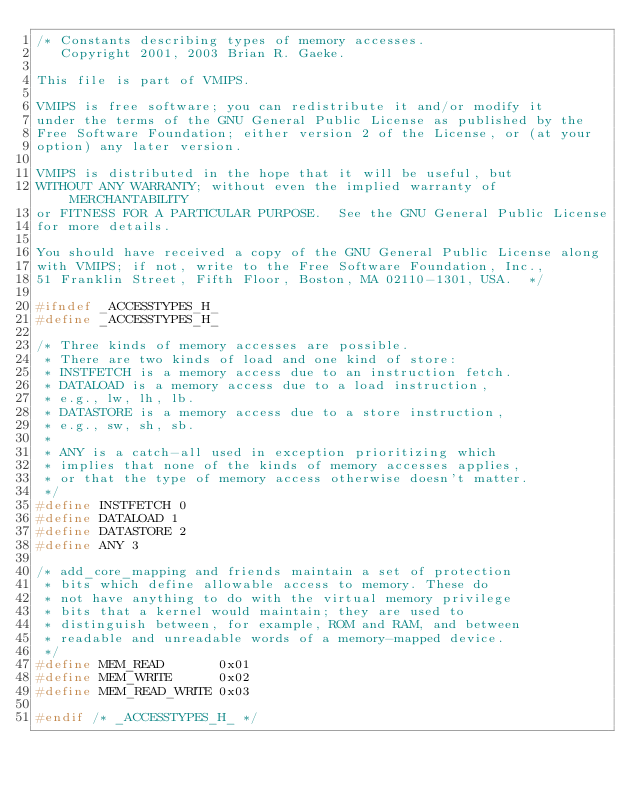Convert code to text. <code><loc_0><loc_0><loc_500><loc_500><_C_>/* Constants describing types of memory accesses.
   Copyright 2001, 2003 Brian R. Gaeke.

This file is part of VMIPS.

VMIPS is free software; you can redistribute it and/or modify it
under the terms of the GNU General Public License as published by the
Free Software Foundation; either version 2 of the License, or (at your
option) any later version.

VMIPS is distributed in the hope that it will be useful, but
WITHOUT ANY WARRANTY; without even the implied warranty of MERCHANTABILITY
or FITNESS FOR A PARTICULAR PURPOSE.  See the GNU General Public License
for more details.

You should have received a copy of the GNU General Public License along
with VMIPS; if not, write to the Free Software Foundation, Inc.,
51 Franklin Street, Fifth Floor, Boston, MA 02110-1301, USA.  */

#ifndef _ACCESSTYPES_H_
#define _ACCESSTYPES_H_

/* Three kinds of memory accesses are possible.
 * There are two kinds of load and one kind of store:
 * INSTFETCH is a memory access due to an instruction fetch.
 * DATALOAD is a memory access due to a load instruction,
 * e.g., lw, lh, lb.
 * DATASTORE is a memory access due to a store instruction,
 * e.g., sw, sh, sb.
 *
 * ANY is a catch-all used in exception prioritizing which
 * implies that none of the kinds of memory accesses applies,
 * or that the type of memory access otherwise doesn't matter.
 */
#define INSTFETCH 0
#define DATALOAD 1
#define DATASTORE 2
#define ANY 3

/* add_core_mapping and friends maintain a set of protection
 * bits which define allowable access to memory. These do
 * not have anything to do with the virtual memory privilege
 * bits that a kernel would maintain; they are used to
 * distinguish between, for example, ROM and RAM, and between
 * readable and unreadable words of a memory-mapped device.
 */
#define MEM_READ       0x01
#define MEM_WRITE      0x02
#define MEM_READ_WRITE 0x03

#endif /* _ACCESSTYPES_H_ */
</code> 